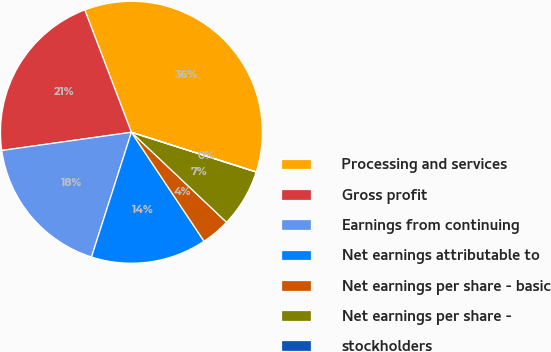<chart> <loc_0><loc_0><loc_500><loc_500><pie_chart><fcel>Processing and services<fcel>Gross profit<fcel>Earnings from continuing<fcel>Net earnings attributable to<fcel>Net earnings per share - basic<fcel>Net earnings per share -<fcel>stockholders<nl><fcel>35.7%<fcel>21.42%<fcel>17.85%<fcel>14.29%<fcel>3.58%<fcel>7.15%<fcel>0.01%<nl></chart> 